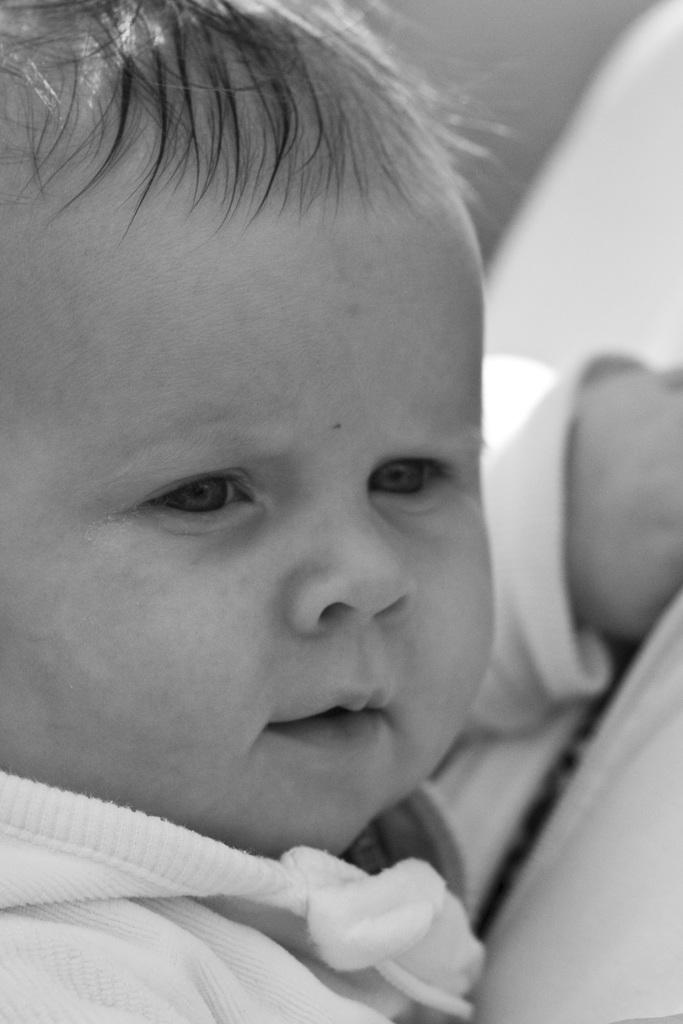What is the main subject of the image? The main subject of the image is a baby. What is the baby wearing in the image? The baby is wearing a white dress in the image. What color scheme is used in the image? The image is black and white. What type of pin can be seen on the baby's dress in the image? There is no pin visible on the baby's dress in the image. What religious symbol is present in the image? There is no religious symbol present in the image. Is there a bike in the image? There is no bike present in the image. 